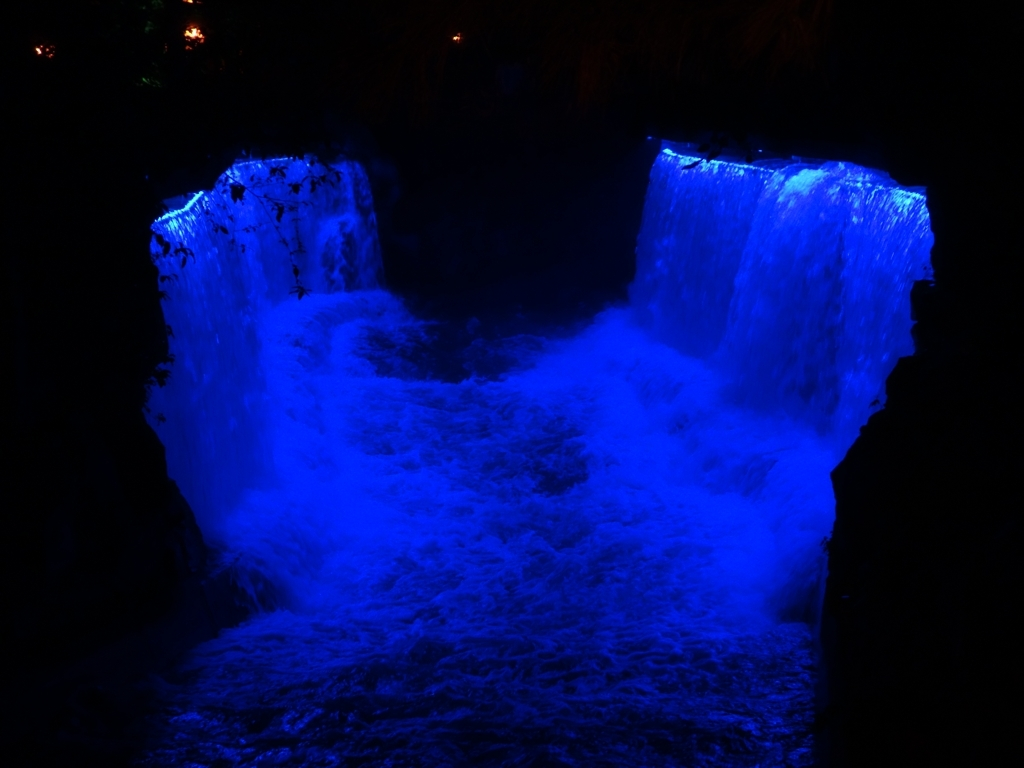How does the lighting affect the perception of the waterfall? The lighting creates a dramatic and mystical atmosphere, highlighting the waterfall’s contours and transforming it into an ethereal blue cascade. It accentuates the intense movement and the inherent power of the waterfall. 